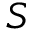Convert formula to latex. <formula><loc_0><loc_0><loc_500><loc_500>S</formula> 